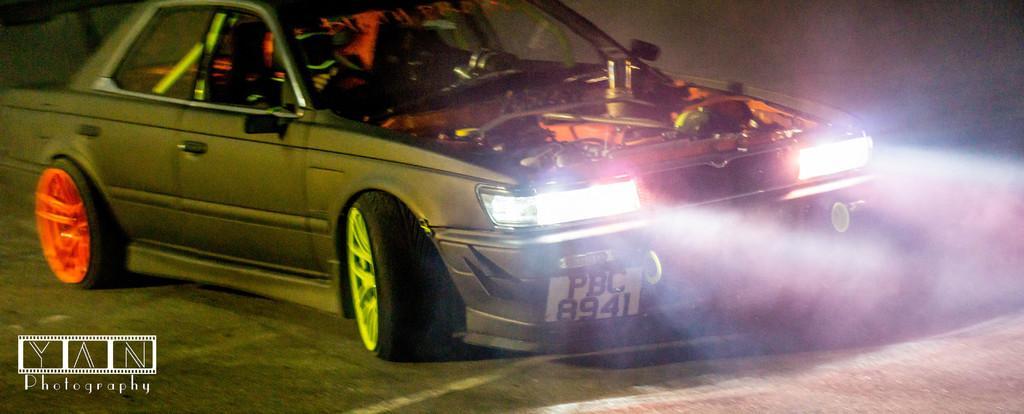Could you give a brief overview of what you see in this image? In this image I see a car and I see the lights over here and I see the engine and I see the different color of wheel rims and I see the road and I see the watermark over here. 